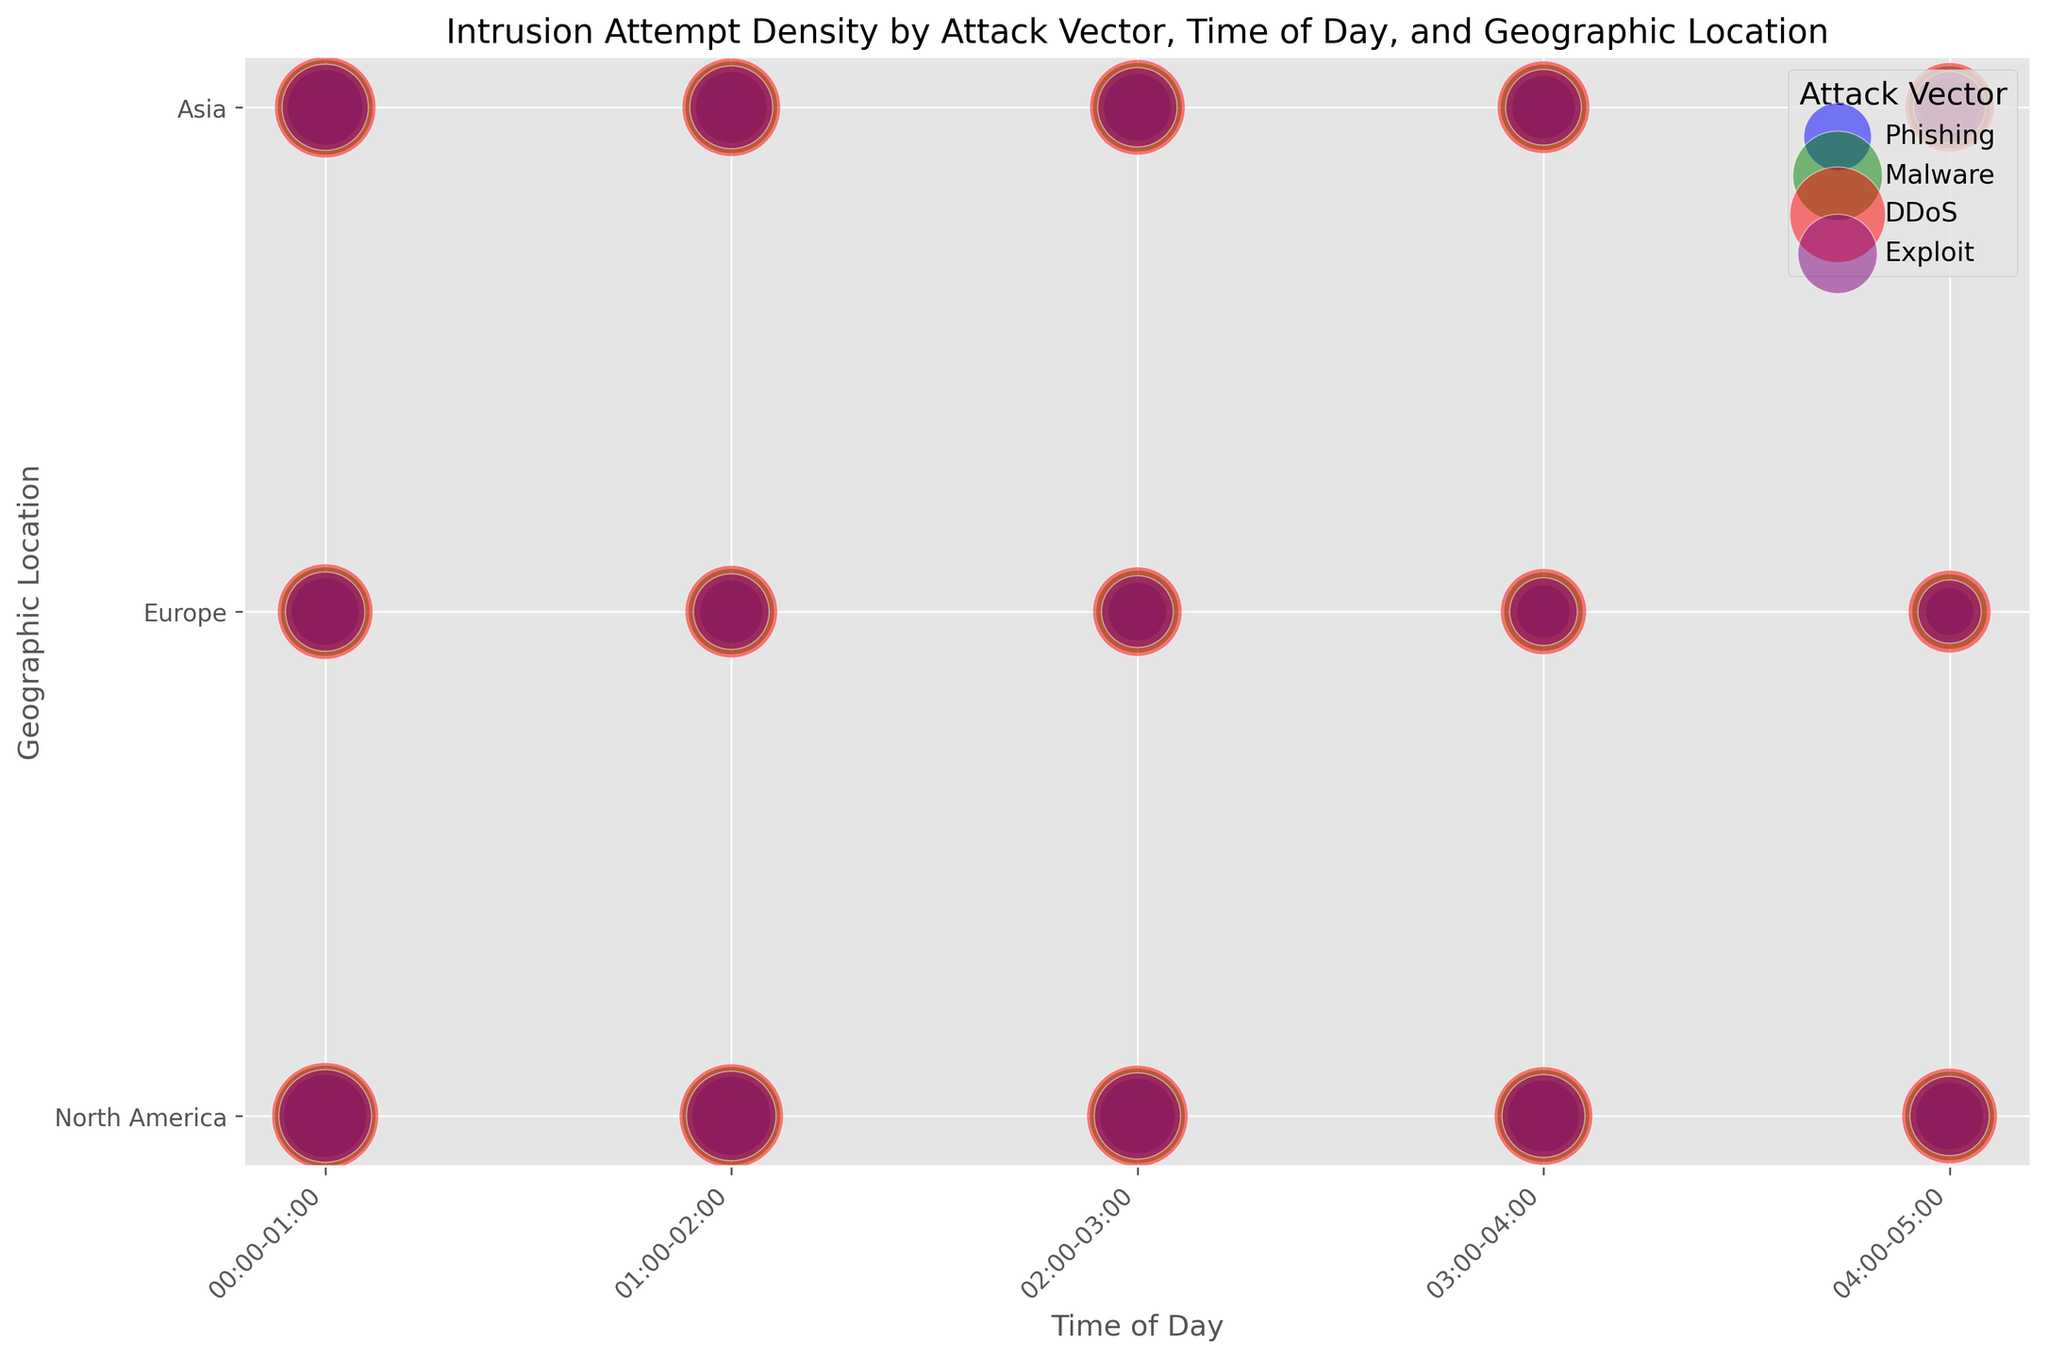What is the most common attack vector between 00:00-01:00 across all locations? To determine the most common attack vector, look at the sizes of the bubbles (indicating the number of intrusion attempts) for each attack vector between 00:00-01:00 across all locations. The largest number of bubbles belong to the DDoS vector.
Answer: DDoS Compare the number of intrusion attempts for Malware and Phishing in North America at 01:00-02:00. Which has more attempts? Look at the bubbles for Malware and Phishing at 01:00-02:00 in North America. The size of the Malware bubble is larger than the Phishing bubble, indicating more intrusion attempts.
Answer: Malware Among all attack vectors, which one shows the smallest bubble in Europe during 03:00-04:00? Examine the bubbles in Europe for the 03:00-04:00 time slot. The smallest bubble belongs to the Phishing vector.
Answer: Phishing What is the total number of intrusion attempts for DDoS at 02:00-03:00 across all locations? Add up the sizes of the DDoS bubbles at 02:00-03:00 for North America, Europe, and Asia. The total is 180 + 140 + 160.
Answer: 480 How does the number of Phishing attempts in Asia vary from 00:00-01:00 to 04:00-05:00? Observe the sizes of the Phishing bubbles in Asia from 00:00-01:00 to 04:00-05:00. They decrease sequentially as follows: 100, 90, 80, 70, 60.
Answer: Decreases What can you infer about the relative sizes of intrusion attempts for Exploit in North America between 00:00-05:00? Look at the sizes of the Exploit bubbles in North America between 00:00-05:00. They start large at 150, gradually decrease to 110.
Answer: Gradually decrease How does the frequency of Malware attempts change over time in Europe? Examine the sizes of the Malware bubbles in Europe over the different time slots. The bubbles sequentially decrease in size from 140, 130, 120, 110, to 100.
Answer: Decreases Which geographical location has the highest number of Malware attempts between 00:00-01:00? Compare the sizes of the Malware bubbles between 00:00-01:00 for North America, Europe, and Asia. The largest bubble belongs to North America.
Answer: North America Which attack vector shows the most significant overall activity in Asia between 00:00-05:00? Compare the sum of the sizes of bubbles for each vector in Asia between 00:00-05:00. DDoS has the largest sizes aggregated over this period.
Answer: DDoS What proportion of Phishing attempts in Europe occur between 03:00-05:00? Calculate the total Phishing attempt values for Europe between 03:00-05:00 and then divide by the total Phishing attempts in Europe. (50+40)/(80+70+60+50+40) = 90/300 = 0.3
Answer: 0.3 